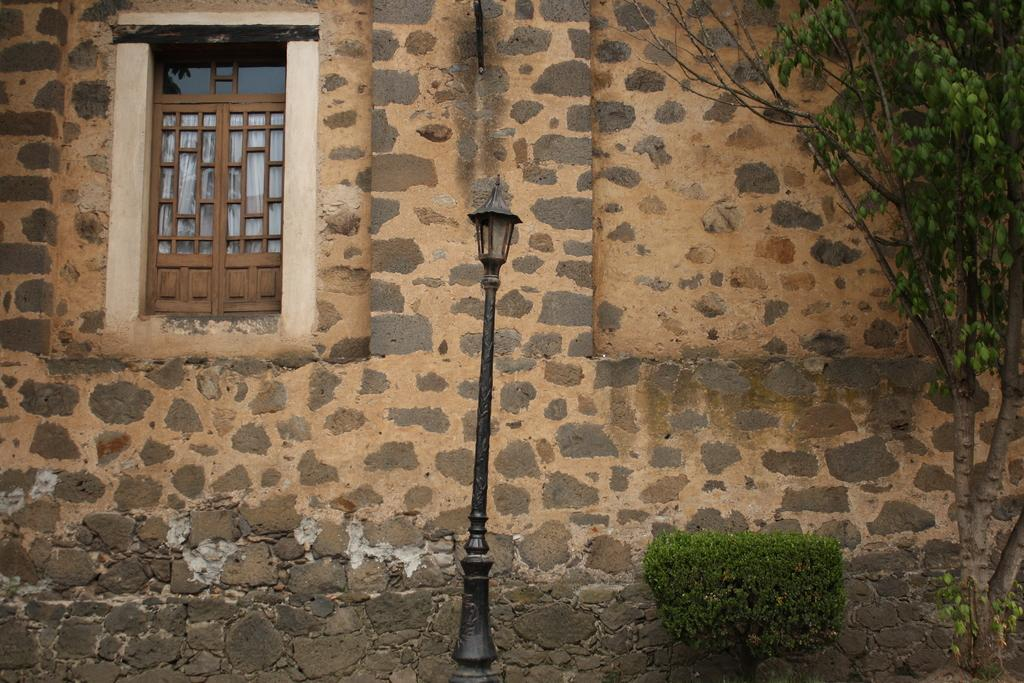What is the main object in the middle of the image? There is a lamp pole in the middle of the image. What can be seen on the left side of the image? There is a window on the left side of the image. Can you describe the material of the wall that the window is part of? The window is part of a stone wall. What type of vegetation is on the right side of the image? There is a tree on the right side of the image. What type of alarm can be heard going off in the image? There is no alarm present in the image, so it cannot be heard. 